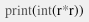Convert code to text. <code><loc_0><loc_0><loc_500><loc_500><_Python_>print(int(r*r))</code> 